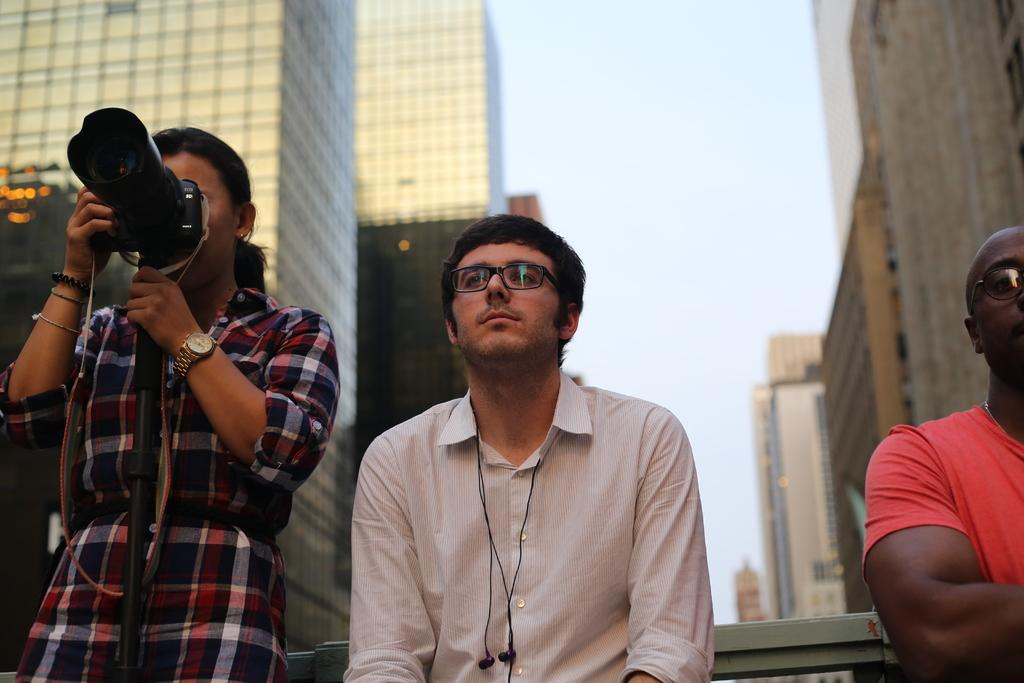How many people are in the image? There are persons standing in the image. What is one of the persons holding? There is a person holding a camera in the image. What can be seen in the distance behind the people? There are buildings visible in the background of the image. What is visible above the buildings in the image? The sky is visible in the background of the image. What type of soup is being served in the image? There is no soup present in the image. Can you see a twig on the person's head in the image? There is no twig visible on any person's head in the image. 